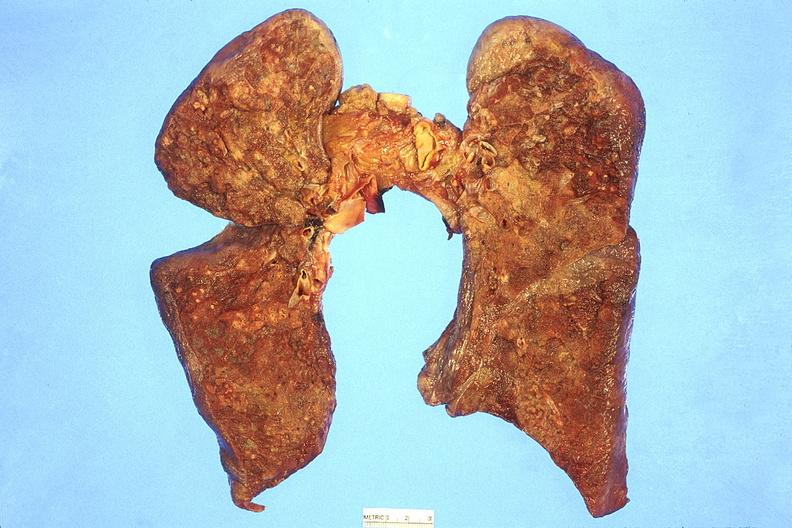where is this?
Answer the question using a single word or phrase. Lung 